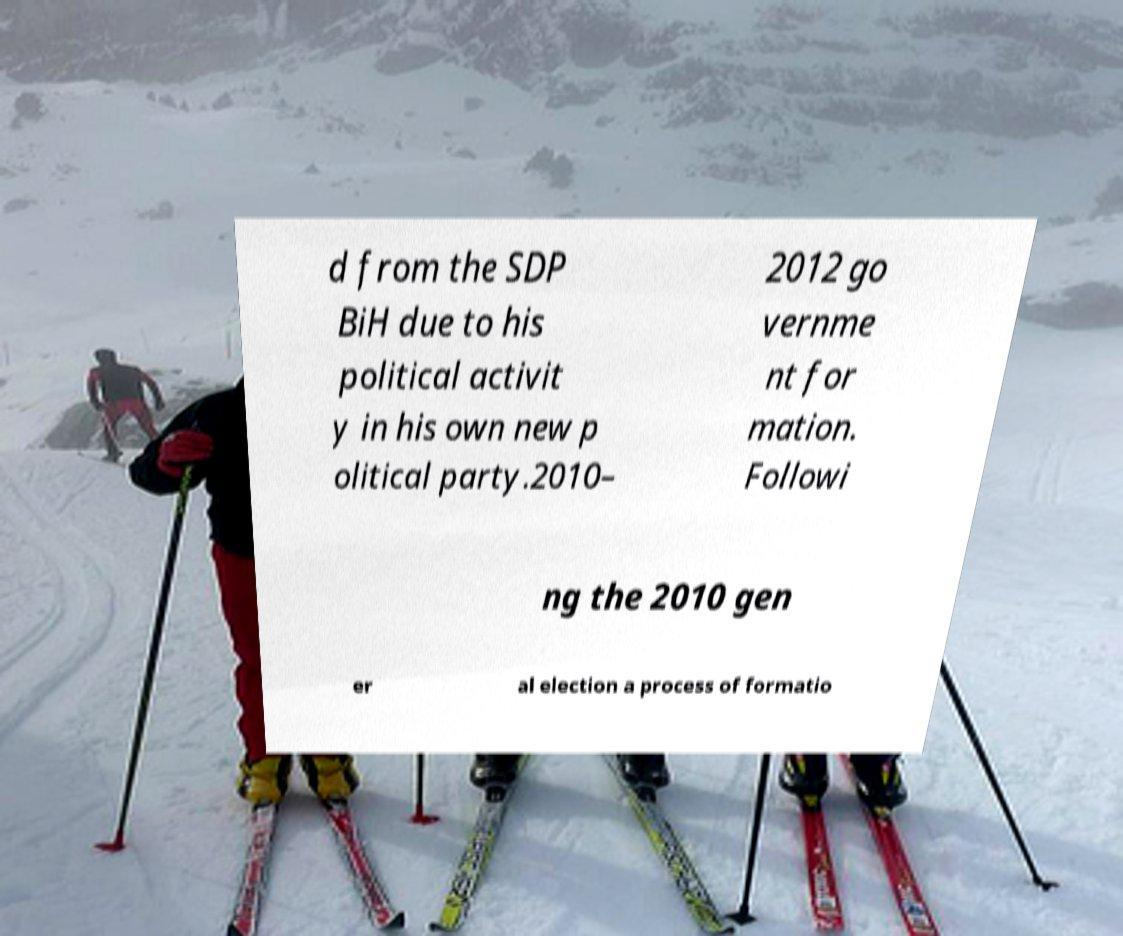Can you accurately transcribe the text from the provided image for me? d from the SDP BiH due to his political activit y in his own new p olitical party.2010– 2012 go vernme nt for mation. Followi ng the 2010 gen er al election a process of formatio 